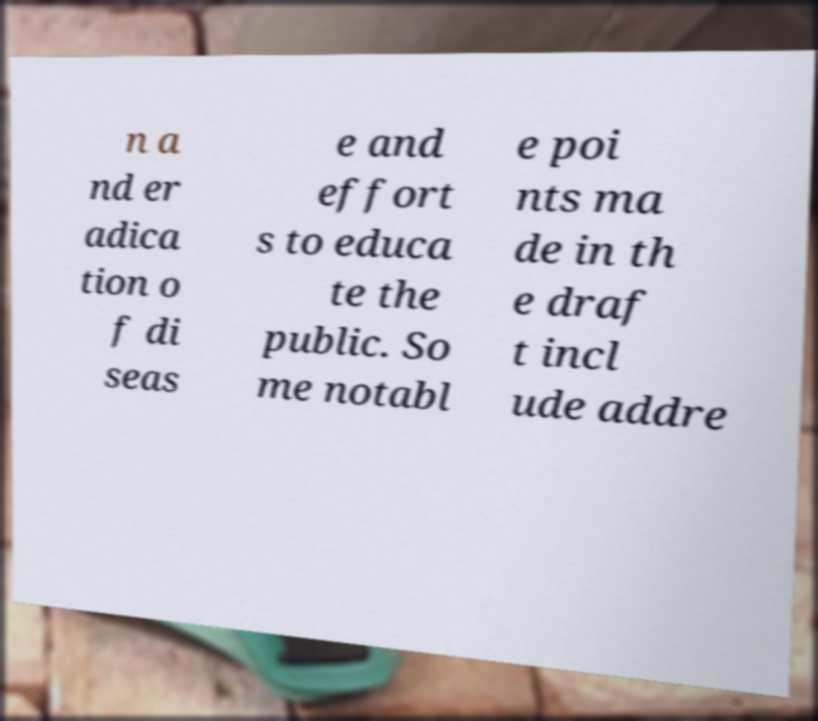Can you accurately transcribe the text from the provided image for me? n a nd er adica tion o f di seas e and effort s to educa te the public. So me notabl e poi nts ma de in th e draf t incl ude addre 